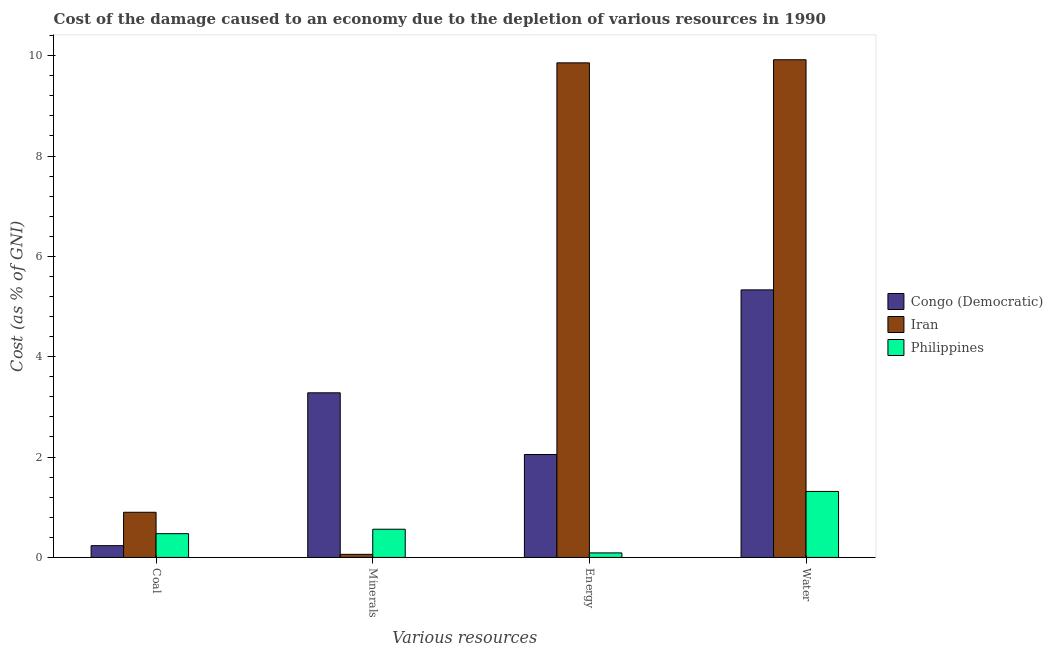How many groups of bars are there?
Ensure brevity in your answer.  4. How many bars are there on the 3rd tick from the left?
Provide a succinct answer. 3. How many bars are there on the 2nd tick from the right?
Provide a short and direct response. 3. What is the label of the 1st group of bars from the left?
Your response must be concise. Coal. What is the cost of damage due to depletion of energy in Philippines?
Ensure brevity in your answer.  0.09. Across all countries, what is the maximum cost of damage due to depletion of energy?
Offer a terse response. 9.86. Across all countries, what is the minimum cost of damage due to depletion of minerals?
Make the answer very short. 0.06. In which country was the cost of damage due to depletion of energy maximum?
Provide a short and direct response. Iran. In which country was the cost of damage due to depletion of coal minimum?
Your answer should be very brief. Congo (Democratic). What is the total cost of damage due to depletion of energy in the graph?
Ensure brevity in your answer.  12. What is the difference between the cost of damage due to depletion of water in Philippines and that in Iran?
Provide a succinct answer. -8.6. What is the difference between the cost of damage due to depletion of energy in Philippines and the cost of damage due to depletion of water in Iran?
Your answer should be compact. -9.83. What is the average cost of damage due to depletion of water per country?
Provide a succinct answer. 5.52. What is the difference between the cost of damage due to depletion of coal and cost of damage due to depletion of energy in Congo (Democratic)?
Your answer should be compact. -1.82. What is the ratio of the cost of damage due to depletion of energy in Philippines to that in Congo (Democratic)?
Provide a short and direct response. 0.04. Is the difference between the cost of damage due to depletion of water in Philippines and Congo (Democratic) greater than the difference between the cost of damage due to depletion of energy in Philippines and Congo (Democratic)?
Your answer should be very brief. No. What is the difference between the highest and the second highest cost of damage due to depletion of minerals?
Ensure brevity in your answer.  2.72. What is the difference between the highest and the lowest cost of damage due to depletion of minerals?
Your response must be concise. 3.22. In how many countries, is the cost of damage due to depletion of energy greater than the average cost of damage due to depletion of energy taken over all countries?
Offer a terse response. 1. Is the sum of the cost of damage due to depletion of water in Congo (Democratic) and Iran greater than the maximum cost of damage due to depletion of minerals across all countries?
Provide a succinct answer. Yes. Is it the case that in every country, the sum of the cost of damage due to depletion of water and cost of damage due to depletion of coal is greater than the sum of cost of damage due to depletion of minerals and cost of damage due to depletion of energy?
Your response must be concise. No. What does the 1st bar from the left in Energy represents?
Offer a very short reply. Congo (Democratic). Is it the case that in every country, the sum of the cost of damage due to depletion of coal and cost of damage due to depletion of minerals is greater than the cost of damage due to depletion of energy?
Offer a very short reply. No. How many bars are there?
Your response must be concise. 12. Are all the bars in the graph horizontal?
Your answer should be very brief. No. How many countries are there in the graph?
Offer a very short reply. 3. Does the graph contain grids?
Ensure brevity in your answer.  No. Where does the legend appear in the graph?
Offer a very short reply. Center right. How many legend labels are there?
Keep it short and to the point. 3. What is the title of the graph?
Provide a short and direct response. Cost of the damage caused to an economy due to the depletion of various resources in 1990 . Does "Haiti" appear as one of the legend labels in the graph?
Your response must be concise. No. What is the label or title of the X-axis?
Make the answer very short. Various resources. What is the label or title of the Y-axis?
Ensure brevity in your answer.  Cost (as % of GNI). What is the Cost (as % of GNI) of Congo (Democratic) in Coal?
Your response must be concise. 0.23. What is the Cost (as % of GNI) of Iran in Coal?
Your response must be concise. 0.9. What is the Cost (as % of GNI) in Philippines in Coal?
Your response must be concise. 0.47. What is the Cost (as % of GNI) in Congo (Democratic) in Minerals?
Ensure brevity in your answer.  3.28. What is the Cost (as % of GNI) in Iran in Minerals?
Give a very brief answer. 0.06. What is the Cost (as % of GNI) in Philippines in Minerals?
Offer a very short reply. 0.56. What is the Cost (as % of GNI) in Congo (Democratic) in Energy?
Your answer should be compact. 2.05. What is the Cost (as % of GNI) in Iran in Energy?
Keep it short and to the point. 9.86. What is the Cost (as % of GNI) in Philippines in Energy?
Your response must be concise. 0.09. What is the Cost (as % of GNI) in Congo (Democratic) in Water?
Keep it short and to the point. 5.33. What is the Cost (as % of GNI) of Iran in Water?
Ensure brevity in your answer.  9.92. What is the Cost (as % of GNI) of Philippines in Water?
Offer a very short reply. 1.31. Across all Various resources, what is the maximum Cost (as % of GNI) in Congo (Democratic)?
Ensure brevity in your answer.  5.33. Across all Various resources, what is the maximum Cost (as % of GNI) of Iran?
Provide a short and direct response. 9.92. Across all Various resources, what is the maximum Cost (as % of GNI) of Philippines?
Offer a terse response. 1.31. Across all Various resources, what is the minimum Cost (as % of GNI) of Congo (Democratic)?
Your answer should be compact. 0.23. Across all Various resources, what is the minimum Cost (as % of GNI) in Iran?
Offer a very short reply. 0.06. Across all Various resources, what is the minimum Cost (as % of GNI) of Philippines?
Keep it short and to the point. 0.09. What is the total Cost (as % of GNI) in Congo (Democratic) in the graph?
Your answer should be compact. 10.9. What is the total Cost (as % of GNI) in Iran in the graph?
Ensure brevity in your answer.  20.74. What is the total Cost (as % of GNI) of Philippines in the graph?
Offer a very short reply. 2.44. What is the difference between the Cost (as % of GNI) in Congo (Democratic) in Coal and that in Minerals?
Give a very brief answer. -3.05. What is the difference between the Cost (as % of GNI) of Iran in Coal and that in Minerals?
Your answer should be compact. 0.84. What is the difference between the Cost (as % of GNI) of Philippines in Coal and that in Minerals?
Provide a short and direct response. -0.09. What is the difference between the Cost (as % of GNI) of Congo (Democratic) in Coal and that in Energy?
Provide a succinct answer. -1.82. What is the difference between the Cost (as % of GNI) of Iran in Coal and that in Energy?
Your answer should be very brief. -8.96. What is the difference between the Cost (as % of GNI) in Philippines in Coal and that in Energy?
Your answer should be compact. 0.38. What is the difference between the Cost (as % of GNI) of Congo (Democratic) in Coal and that in Water?
Provide a short and direct response. -5.1. What is the difference between the Cost (as % of GNI) of Iran in Coal and that in Water?
Provide a short and direct response. -9.02. What is the difference between the Cost (as % of GNI) in Philippines in Coal and that in Water?
Provide a succinct answer. -0.84. What is the difference between the Cost (as % of GNI) in Congo (Democratic) in Minerals and that in Energy?
Ensure brevity in your answer.  1.23. What is the difference between the Cost (as % of GNI) in Iran in Minerals and that in Energy?
Keep it short and to the point. -9.79. What is the difference between the Cost (as % of GNI) in Philippines in Minerals and that in Energy?
Offer a very short reply. 0.47. What is the difference between the Cost (as % of GNI) of Congo (Democratic) in Minerals and that in Water?
Ensure brevity in your answer.  -2.05. What is the difference between the Cost (as % of GNI) in Iran in Minerals and that in Water?
Offer a very short reply. -9.86. What is the difference between the Cost (as % of GNI) in Philippines in Minerals and that in Water?
Ensure brevity in your answer.  -0.75. What is the difference between the Cost (as % of GNI) of Congo (Democratic) in Energy and that in Water?
Provide a short and direct response. -3.28. What is the difference between the Cost (as % of GNI) of Iran in Energy and that in Water?
Provide a short and direct response. -0.06. What is the difference between the Cost (as % of GNI) in Philippines in Energy and that in Water?
Your response must be concise. -1.22. What is the difference between the Cost (as % of GNI) in Congo (Democratic) in Coal and the Cost (as % of GNI) in Iran in Minerals?
Your answer should be very brief. 0.17. What is the difference between the Cost (as % of GNI) of Congo (Democratic) in Coal and the Cost (as % of GNI) of Philippines in Minerals?
Provide a short and direct response. -0.33. What is the difference between the Cost (as % of GNI) in Iran in Coal and the Cost (as % of GNI) in Philippines in Minerals?
Offer a terse response. 0.34. What is the difference between the Cost (as % of GNI) of Congo (Democratic) in Coal and the Cost (as % of GNI) of Iran in Energy?
Offer a very short reply. -9.62. What is the difference between the Cost (as % of GNI) of Congo (Democratic) in Coal and the Cost (as % of GNI) of Philippines in Energy?
Provide a succinct answer. 0.14. What is the difference between the Cost (as % of GNI) in Iran in Coal and the Cost (as % of GNI) in Philippines in Energy?
Provide a short and direct response. 0.81. What is the difference between the Cost (as % of GNI) of Congo (Democratic) in Coal and the Cost (as % of GNI) of Iran in Water?
Give a very brief answer. -9.68. What is the difference between the Cost (as % of GNI) of Congo (Democratic) in Coal and the Cost (as % of GNI) of Philippines in Water?
Your response must be concise. -1.08. What is the difference between the Cost (as % of GNI) of Iran in Coal and the Cost (as % of GNI) of Philippines in Water?
Ensure brevity in your answer.  -0.41. What is the difference between the Cost (as % of GNI) in Congo (Democratic) in Minerals and the Cost (as % of GNI) in Iran in Energy?
Make the answer very short. -6.58. What is the difference between the Cost (as % of GNI) of Congo (Democratic) in Minerals and the Cost (as % of GNI) of Philippines in Energy?
Your answer should be very brief. 3.19. What is the difference between the Cost (as % of GNI) in Iran in Minerals and the Cost (as % of GNI) in Philippines in Energy?
Ensure brevity in your answer.  -0.03. What is the difference between the Cost (as % of GNI) of Congo (Democratic) in Minerals and the Cost (as % of GNI) of Iran in Water?
Your answer should be compact. -6.64. What is the difference between the Cost (as % of GNI) in Congo (Democratic) in Minerals and the Cost (as % of GNI) in Philippines in Water?
Keep it short and to the point. 1.97. What is the difference between the Cost (as % of GNI) in Iran in Minerals and the Cost (as % of GNI) in Philippines in Water?
Keep it short and to the point. -1.25. What is the difference between the Cost (as % of GNI) of Congo (Democratic) in Energy and the Cost (as % of GNI) of Iran in Water?
Keep it short and to the point. -7.87. What is the difference between the Cost (as % of GNI) in Congo (Democratic) in Energy and the Cost (as % of GNI) in Philippines in Water?
Provide a short and direct response. 0.74. What is the difference between the Cost (as % of GNI) in Iran in Energy and the Cost (as % of GNI) in Philippines in Water?
Your answer should be compact. 8.54. What is the average Cost (as % of GNI) of Congo (Democratic) per Various resources?
Your answer should be compact. 2.72. What is the average Cost (as % of GNI) in Iran per Various resources?
Your answer should be very brief. 5.18. What is the average Cost (as % of GNI) in Philippines per Various resources?
Provide a succinct answer. 0.61. What is the difference between the Cost (as % of GNI) of Congo (Democratic) and Cost (as % of GNI) of Iran in Coal?
Offer a terse response. -0.67. What is the difference between the Cost (as % of GNI) of Congo (Democratic) and Cost (as % of GNI) of Philippines in Coal?
Ensure brevity in your answer.  -0.24. What is the difference between the Cost (as % of GNI) in Iran and Cost (as % of GNI) in Philippines in Coal?
Your answer should be compact. 0.43. What is the difference between the Cost (as % of GNI) in Congo (Democratic) and Cost (as % of GNI) in Iran in Minerals?
Your answer should be compact. 3.22. What is the difference between the Cost (as % of GNI) in Congo (Democratic) and Cost (as % of GNI) in Philippines in Minerals?
Offer a terse response. 2.72. What is the difference between the Cost (as % of GNI) in Iran and Cost (as % of GNI) in Philippines in Minerals?
Offer a very short reply. -0.5. What is the difference between the Cost (as % of GNI) of Congo (Democratic) and Cost (as % of GNI) of Iran in Energy?
Offer a very short reply. -7.81. What is the difference between the Cost (as % of GNI) in Congo (Democratic) and Cost (as % of GNI) in Philippines in Energy?
Make the answer very short. 1.96. What is the difference between the Cost (as % of GNI) of Iran and Cost (as % of GNI) of Philippines in Energy?
Provide a short and direct response. 9.77. What is the difference between the Cost (as % of GNI) of Congo (Democratic) and Cost (as % of GNI) of Iran in Water?
Make the answer very short. -4.59. What is the difference between the Cost (as % of GNI) in Congo (Democratic) and Cost (as % of GNI) in Philippines in Water?
Your response must be concise. 4.02. What is the difference between the Cost (as % of GNI) in Iran and Cost (as % of GNI) in Philippines in Water?
Keep it short and to the point. 8.6. What is the ratio of the Cost (as % of GNI) in Congo (Democratic) in Coal to that in Minerals?
Provide a succinct answer. 0.07. What is the ratio of the Cost (as % of GNI) in Iran in Coal to that in Minerals?
Your response must be concise. 14.58. What is the ratio of the Cost (as % of GNI) in Philippines in Coal to that in Minerals?
Your answer should be very brief. 0.84. What is the ratio of the Cost (as % of GNI) in Congo (Democratic) in Coal to that in Energy?
Give a very brief answer. 0.11. What is the ratio of the Cost (as % of GNI) in Iran in Coal to that in Energy?
Give a very brief answer. 0.09. What is the ratio of the Cost (as % of GNI) in Philippines in Coal to that in Energy?
Offer a very short reply. 5.25. What is the ratio of the Cost (as % of GNI) in Congo (Democratic) in Coal to that in Water?
Make the answer very short. 0.04. What is the ratio of the Cost (as % of GNI) of Iran in Coal to that in Water?
Your response must be concise. 0.09. What is the ratio of the Cost (as % of GNI) in Philippines in Coal to that in Water?
Your answer should be compact. 0.36. What is the ratio of the Cost (as % of GNI) of Congo (Democratic) in Minerals to that in Energy?
Offer a very short reply. 1.6. What is the ratio of the Cost (as % of GNI) in Iran in Minerals to that in Energy?
Ensure brevity in your answer.  0.01. What is the ratio of the Cost (as % of GNI) of Philippines in Minerals to that in Energy?
Provide a short and direct response. 6.23. What is the ratio of the Cost (as % of GNI) in Congo (Democratic) in Minerals to that in Water?
Your response must be concise. 0.62. What is the ratio of the Cost (as % of GNI) of Iran in Minerals to that in Water?
Ensure brevity in your answer.  0.01. What is the ratio of the Cost (as % of GNI) in Philippines in Minerals to that in Water?
Provide a succinct answer. 0.43. What is the ratio of the Cost (as % of GNI) of Congo (Democratic) in Energy to that in Water?
Your answer should be compact. 0.38. What is the ratio of the Cost (as % of GNI) of Iran in Energy to that in Water?
Provide a succinct answer. 0.99. What is the ratio of the Cost (as % of GNI) of Philippines in Energy to that in Water?
Keep it short and to the point. 0.07. What is the difference between the highest and the second highest Cost (as % of GNI) in Congo (Democratic)?
Keep it short and to the point. 2.05. What is the difference between the highest and the second highest Cost (as % of GNI) of Iran?
Give a very brief answer. 0.06. What is the difference between the highest and the second highest Cost (as % of GNI) of Philippines?
Provide a short and direct response. 0.75. What is the difference between the highest and the lowest Cost (as % of GNI) of Congo (Democratic)?
Provide a succinct answer. 5.1. What is the difference between the highest and the lowest Cost (as % of GNI) in Iran?
Your response must be concise. 9.86. What is the difference between the highest and the lowest Cost (as % of GNI) in Philippines?
Ensure brevity in your answer.  1.22. 